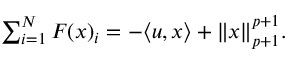Convert formula to latex. <formula><loc_0><loc_0><loc_500><loc_500>\begin{array} { r } { \sum _ { i = 1 } ^ { N } F ( { \boldsymbol x } ) _ { i } = - \langle u , { \boldsymbol x } \rangle + \| { \boldsymbol x } \| _ { p + 1 } ^ { p + 1 } . } \end{array}</formula> 